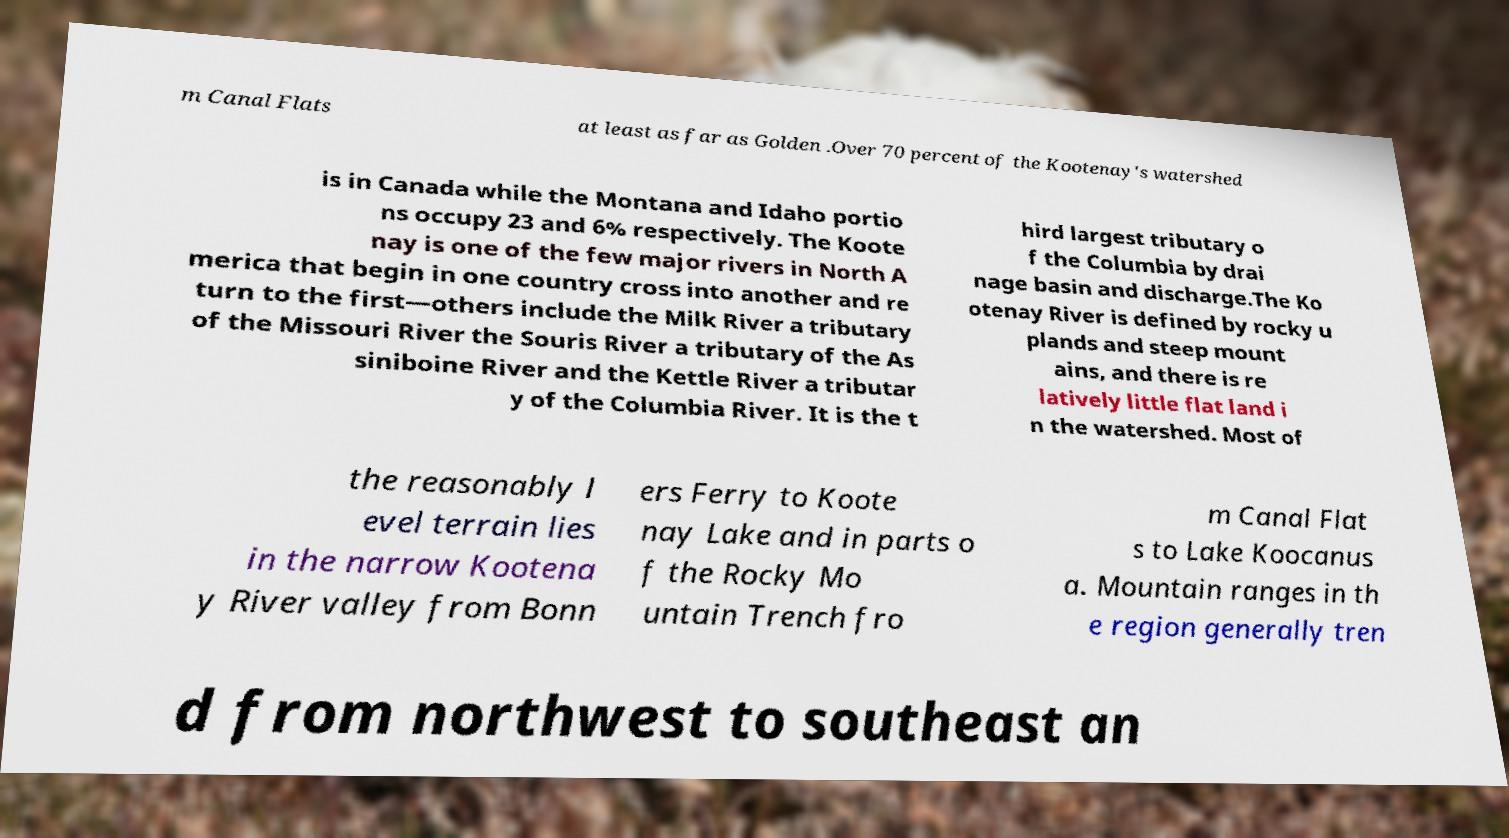For documentation purposes, I need the text within this image transcribed. Could you provide that? m Canal Flats at least as far as Golden .Over 70 percent of the Kootenay's watershed is in Canada while the Montana and Idaho portio ns occupy 23 and 6% respectively. The Koote nay is one of the few major rivers in North A merica that begin in one country cross into another and re turn to the first—others include the Milk River a tributary of the Missouri River the Souris River a tributary of the As siniboine River and the Kettle River a tributar y of the Columbia River. It is the t hird largest tributary o f the Columbia by drai nage basin and discharge.The Ko otenay River is defined by rocky u plands and steep mount ains, and there is re latively little flat land i n the watershed. Most of the reasonably l evel terrain lies in the narrow Kootena y River valley from Bonn ers Ferry to Koote nay Lake and in parts o f the Rocky Mo untain Trench fro m Canal Flat s to Lake Koocanus a. Mountain ranges in th e region generally tren d from northwest to southeast an 